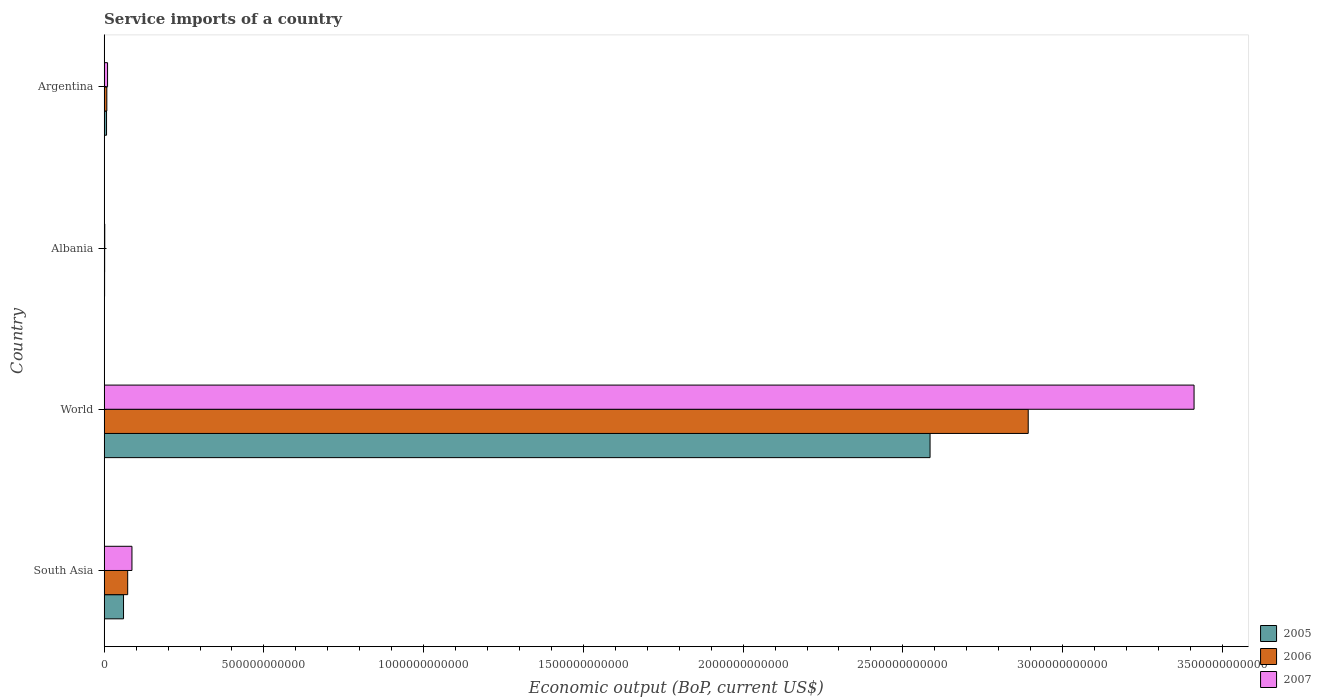Are the number of bars per tick equal to the number of legend labels?
Make the answer very short. Yes. Are the number of bars on each tick of the Y-axis equal?
Your answer should be compact. Yes. How many bars are there on the 3rd tick from the bottom?
Give a very brief answer. 3. In how many cases, is the number of bars for a given country not equal to the number of legend labels?
Your answer should be very brief. 0. What is the service imports in 2007 in Albania?
Provide a succinct answer. 1.92e+09. Across all countries, what is the maximum service imports in 2005?
Your response must be concise. 2.59e+12. Across all countries, what is the minimum service imports in 2006?
Make the answer very short. 1.57e+09. In which country was the service imports in 2005 minimum?
Provide a short and direct response. Albania. What is the total service imports in 2006 in the graph?
Ensure brevity in your answer.  2.98e+12. What is the difference between the service imports in 2005 in Argentina and that in South Asia?
Give a very brief answer. -5.32e+1. What is the difference between the service imports in 2007 in Argentina and the service imports in 2006 in World?
Give a very brief answer. -2.88e+12. What is the average service imports in 2005 per country?
Provide a short and direct response. 6.64e+11. What is the difference between the service imports in 2006 and service imports in 2007 in Albania?
Provide a short and direct response. -3.51e+08. What is the ratio of the service imports in 2007 in Albania to that in South Asia?
Provide a succinct answer. 0.02. What is the difference between the highest and the second highest service imports in 2006?
Provide a short and direct response. 2.82e+12. What is the difference between the highest and the lowest service imports in 2005?
Give a very brief answer. 2.58e+12. Is the sum of the service imports in 2005 in Albania and World greater than the maximum service imports in 2007 across all countries?
Your answer should be very brief. No. What does the 2nd bar from the bottom in World represents?
Offer a very short reply. 2006. Is it the case that in every country, the sum of the service imports in 2007 and service imports in 2006 is greater than the service imports in 2005?
Provide a short and direct response. Yes. How many bars are there?
Keep it short and to the point. 12. How many countries are there in the graph?
Your answer should be compact. 4. What is the difference between two consecutive major ticks on the X-axis?
Keep it short and to the point. 5.00e+11. Are the values on the major ticks of X-axis written in scientific E-notation?
Offer a terse response. No. Does the graph contain any zero values?
Your response must be concise. No. Where does the legend appear in the graph?
Give a very brief answer. Bottom right. How are the legend labels stacked?
Give a very brief answer. Vertical. What is the title of the graph?
Give a very brief answer. Service imports of a country. Does "1982" appear as one of the legend labels in the graph?
Your answer should be compact. No. What is the label or title of the X-axis?
Provide a succinct answer. Economic output (BoP, current US$). What is the Economic output (BoP, current US$) of 2005 in South Asia?
Your response must be concise. 6.07e+1. What is the Economic output (BoP, current US$) of 2006 in South Asia?
Provide a short and direct response. 7.37e+1. What is the Economic output (BoP, current US$) in 2007 in South Asia?
Ensure brevity in your answer.  8.70e+1. What is the Economic output (BoP, current US$) in 2005 in World?
Provide a short and direct response. 2.59e+12. What is the Economic output (BoP, current US$) of 2006 in World?
Offer a terse response. 2.89e+12. What is the Economic output (BoP, current US$) of 2007 in World?
Provide a succinct answer. 3.41e+12. What is the Economic output (BoP, current US$) in 2005 in Albania?
Ensure brevity in your answer.  1.38e+09. What is the Economic output (BoP, current US$) of 2006 in Albania?
Your answer should be very brief. 1.57e+09. What is the Economic output (BoP, current US$) of 2007 in Albania?
Your answer should be compact. 1.92e+09. What is the Economic output (BoP, current US$) in 2005 in Argentina?
Make the answer very short. 7.50e+09. What is the Economic output (BoP, current US$) in 2006 in Argentina?
Keep it short and to the point. 8.39e+09. What is the Economic output (BoP, current US$) in 2007 in Argentina?
Ensure brevity in your answer.  1.07e+1. Across all countries, what is the maximum Economic output (BoP, current US$) of 2005?
Provide a succinct answer. 2.59e+12. Across all countries, what is the maximum Economic output (BoP, current US$) in 2006?
Offer a terse response. 2.89e+12. Across all countries, what is the maximum Economic output (BoP, current US$) of 2007?
Provide a succinct answer. 3.41e+12. Across all countries, what is the minimum Economic output (BoP, current US$) in 2005?
Your response must be concise. 1.38e+09. Across all countries, what is the minimum Economic output (BoP, current US$) of 2006?
Keep it short and to the point. 1.57e+09. Across all countries, what is the minimum Economic output (BoP, current US$) in 2007?
Offer a very short reply. 1.92e+09. What is the total Economic output (BoP, current US$) in 2005 in the graph?
Give a very brief answer. 2.65e+12. What is the total Economic output (BoP, current US$) of 2006 in the graph?
Your response must be concise. 2.98e+12. What is the total Economic output (BoP, current US$) of 2007 in the graph?
Make the answer very short. 3.51e+12. What is the difference between the Economic output (BoP, current US$) of 2005 in South Asia and that in World?
Offer a terse response. -2.52e+12. What is the difference between the Economic output (BoP, current US$) of 2006 in South Asia and that in World?
Make the answer very short. -2.82e+12. What is the difference between the Economic output (BoP, current US$) of 2007 in South Asia and that in World?
Offer a very short reply. -3.32e+12. What is the difference between the Economic output (BoP, current US$) of 2005 in South Asia and that in Albania?
Keep it short and to the point. 5.93e+1. What is the difference between the Economic output (BoP, current US$) in 2006 in South Asia and that in Albania?
Offer a very short reply. 7.21e+1. What is the difference between the Economic output (BoP, current US$) of 2007 in South Asia and that in Albania?
Keep it short and to the point. 8.51e+1. What is the difference between the Economic output (BoP, current US$) of 2005 in South Asia and that in Argentina?
Offer a terse response. 5.32e+1. What is the difference between the Economic output (BoP, current US$) in 2006 in South Asia and that in Argentina?
Provide a short and direct response. 6.53e+1. What is the difference between the Economic output (BoP, current US$) of 2007 in South Asia and that in Argentina?
Offer a terse response. 7.63e+1. What is the difference between the Economic output (BoP, current US$) of 2005 in World and that in Albania?
Your answer should be compact. 2.58e+12. What is the difference between the Economic output (BoP, current US$) in 2006 in World and that in Albania?
Make the answer very short. 2.89e+12. What is the difference between the Economic output (BoP, current US$) of 2007 in World and that in Albania?
Offer a terse response. 3.41e+12. What is the difference between the Economic output (BoP, current US$) of 2005 in World and that in Argentina?
Give a very brief answer. 2.58e+12. What is the difference between the Economic output (BoP, current US$) of 2006 in World and that in Argentina?
Keep it short and to the point. 2.88e+12. What is the difference between the Economic output (BoP, current US$) in 2007 in World and that in Argentina?
Provide a succinct answer. 3.40e+12. What is the difference between the Economic output (BoP, current US$) in 2005 in Albania and that in Argentina?
Make the answer very short. -6.11e+09. What is the difference between the Economic output (BoP, current US$) of 2006 in Albania and that in Argentina?
Your answer should be very brief. -6.81e+09. What is the difference between the Economic output (BoP, current US$) in 2007 in Albania and that in Argentina?
Your response must be concise. -8.78e+09. What is the difference between the Economic output (BoP, current US$) in 2005 in South Asia and the Economic output (BoP, current US$) in 2006 in World?
Give a very brief answer. -2.83e+12. What is the difference between the Economic output (BoP, current US$) in 2005 in South Asia and the Economic output (BoP, current US$) in 2007 in World?
Provide a short and direct response. -3.35e+12. What is the difference between the Economic output (BoP, current US$) in 2006 in South Asia and the Economic output (BoP, current US$) in 2007 in World?
Your answer should be very brief. -3.34e+12. What is the difference between the Economic output (BoP, current US$) in 2005 in South Asia and the Economic output (BoP, current US$) in 2006 in Albania?
Offer a very short reply. 5.91e+1. What is the difference between the Economic output (BoP, current US$) in 2005 in South Asia and the Economic output (BoP, current US$) in 2007 in Albania?
Your answer should be very brief. 5.87e+1. What is the difference between the Economic output (BoP, current US$) of 2006 in South Asia and the Economic output (BoP, current US$) of 2007 in Albania?
Make the answer very short. 7.18e+1. What is the difference between the Economic output (BoP, current US$) in 2005 in South Asia and the Economic output (BoP, current US$) in 2006 in Argentina?
Your response must be concise. 5.23e+1. What is the difference between the Economic output (BoP, current US$) of 2005 in South Asia and the Economic output (BoP, current US$) of 2007 in Argentina?
Keep it short and to the point. 5.00e+1. What is the difference between the Economic output (BoP, current US$) in 2006 in South Asia and the Economic output (BoP, current US$) in 2007 in Argentina?
Make the answer very short. 6.30e+1. What is the difference between the Economic output (BoP, current US$) in 2005 in World and the Economic output (BoP, current US$) in 2006 in Albania?
Your answer should be very brief. 2.58e+12. What is the difference between the Economic output (BoP, current US$) of 2005 in World and the Economic output (BoP, current US$) of 2007 in Albania?
Your answer should be very brief. 2.58e+12. What is the difference between the Economic output (BoP, current US$) of 2006 in World and the Economic output (BoP, current US$) of 2007 in Albania?
Ensure brevity in your answer.  2.89e+12. What is the difference between the Economic output (BoP, current US$) in 2005 in World and the Economic output (BoP, current US$) in 2006 in Argentina?
Ensure brevity in your answer.  2.58e+12. What is the difference between the Economic output (BoP, current US$) in 2005 in World and the Economic output (BoP, current US$) in 2007 in Argentina?
Give a very brief answer. 2.57e+12. What is the difference between the Economic output (BoP, current US$) in 2006 in World and the Economic output (BoP, current US$) in 2007 in Argentina?
Ensure brevity in your answer.  2.88e+12. What is the difference between the Economic output (BoP, current US$) in 2005 in Albania and the Economic output (BoP, current US$) in 2006 in Argentina?
Make the answer very short. -7.00e+09. What is the difference between the Economic output (BoP, current US$) of 2005 in Albania and the Economic output (BoP, current US$) of 2007 in Argentina?
Ensure brevity in your answer.  -9.32e+09. What is the difference between the Economic output (BoP, current US$) of 2006 in Albania and the Economic output (BoP, current US$) of 2007 in Argentina?
Your answer should be very brief. -9.13e+09. What is the average Economic output (BoP, current US$) of 2005 per country?
Your answer should be very brief. 6.64e+11. What is the average Economic output (BoP, current US$) of 2006 per country?
Make the answer very short. 7.44e+11. What is the average Economic output (BoP, current US$) in 2007 per country?
Make the answer very short. 8.78e+11. What is the difference between the Economic output (BoP, current US$) in 2005 and Economic output (BoP, current US$) in 2006 in South Asia?
Offer a terse response. -1.30e+1. What is the difference between the Economic output (BoP, current US$) of 2005 and Economic output (BoP, current US$) of 2007 in South Asia?
Provide a succinct answer. -2.64e+1. What is the difference between the Economic output (BoP, current US$) of 2006 and Economic output (BoP, current US$) of 2007 in South Asia?
Make the answer very short. -1.34e+1. What is the difference between the Economic output (BoP, current US$) of 2005 and Economic output (BoP, current US$) of 2006 in World?
Make the answer very short. -3.07e+11. What is the difference between the Economic output (BoP, current US$) of 2005 and Economic output (BoP, current US$) of 2007 in World?
Your answer should be very brief. -8.26e+11. What is the difference between the Economic output (BoP, current US$) in 2006 and Economic output (BoP, current US$) in 2007 in World?
Offer a very short reply. -5.19e+11. What is the difference between the Economic output (BoP, current US$) of 2005 and Economic output (BoP, current US$) of 2006 in Albania?
Your answer should be compact. -1.90e+08. What is the difference between the Economic output (BoP, current US$) in 2005 and Economic output (BoP, current US$) in 2007 in Albania?
Keep it short and to the point. -5.42e+08. What is the difference between the Economic output (BoP, current US$) in 2006 and Economic output (BoP, current US$) in 2007 in Albania?
Your response must be concise. -3.51e+08. What is the difference between the Economic output (BoP, current US$) in 2005 and Economic output (BoP, current US$) in 2006 in Argentina?
Give a very brief answer. -8.89e+08. What is the difference between the Economic output (BoP, current US$) in 2005 and Economic output (BoP, current US$) in 2007 in Argentina?
Your answer should be very brief. -3.20e+09. What is the difference between the Economic output (BoP, current US$) of 2006 and Economic output (BoP, current US$) of 2007 in Argentina?
Provide a short and direct response. -2.32e+09. What is the ratio of the Economic output (BoP, current US$) of 2005 in South Asia to that in World?
Your answer should be very brief. 0.02. What is the ratio of the Economic output (BoP, current US$) in 2006 in South Asia to that in World?
Offer a terse response. 0.03. What is the ratio of the Economic output (BoP, current US$) in 2007 in South Asia to that in World?
Provide a short and direct response. 0.03. What is the ratio of the Economic output (BoP, current US$) in 2005 in South Asia to that in Albania?
Offer a very short reply. 43.87. What is the ratio of the Economic output (BoP, current US$) of 2006 in South Asia to that in Albania?
Offer a terse response. 46.83. What is the ratio of the Economic output (BoP, current US$) of 2007 in South Asia to that in Albania?
Offer a terse response. 45.22. What is the ratio of the Economic output (BoP, current US$) in 2005 in South Asia to that in Argentina?
Provide a succinct answer. 8.09. What is the ratio of the Economic output (BoP, current US$) of 2006 in South Asia to that in Argentina?
Your response must be concise. 8.79. What is the ratio of the Economic output (BoP, current US$) of 2007 in South Asia to that in Argentina?
Your response must be concise. 8.13. What is the ratio of the Economic output (BoP, current US$) in 2005 in World to that in Albania?
Make the answer very short. 1869.34. What is the ratio of the Economic output (BoP, current US$) in 2006 in World to that in Albania?
Keep it short and to the point. 1838.32. What is the ratio of the Economic output (BoP, current US$) in 2007 in World to that in Albania?
Offer a terse response. 1772.68. What is the ratio of the Economic output (BoP, current US$) of 2005 in World to that in Argentina?
Offer a terse response. 344.82. What is the ratio of the Economic output (BoP, current US$) in 2006 in World to that in Argentina?
Make the answer very short. 344.91. What is the ratio of the Economic output (BoP, current US$) of 2007 in World to that in Argentina?
Ensure brevity in your answer.  318.77. What is the ratio of the Economic output (BoP, current US$) of 2005 in Albania to that in Argentina?
Offer a very short reply. 0.18. What is the ratio of the Economic output (BoP, current US$) in 2006 in Albania to that in Argentina?
Your answer should be very brief. 0.19. What is the ratio of the Economic output (BoP, current US$) in 2007 in Albania to that in Argentina?
Your answer should be compact. 0.18. What is the difference between the highest and the second highest Economic output (BoP, current US$) in 2005?
Your answer should be compact. 2.52e+12. What is the difference between the highest and the second highest Economic output (BoP, current US$) in 2006?
Your response must be concise. 2.82e+12. What is the difference between the highest and the second highest Economic output (BoP, current US$) in 2007?
Ensure brevity in your answer.  3.32e+12. What is the difference between the highest and the lowest Economic output (BoP, current US$) in 2005?
Your response must be concise. 2.58e+12. What is the difference between the highest and the lowest Economic output (BoP, current US$) in 2006?
Provide a succinct answer. 2.89e+12. What is the difference between the highest and the lowest Economic output (BoP, current US$) in 2007?
Provide a succinct answer. 3.41e+12. 